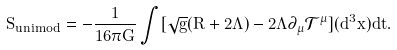Convert formula to latex. <formula><loc_0><loc_0><loc_500><loc_500>S _ { u n i m o d } = - \frac { 1 } { 1 6 \pi G } \int [ \sqrt { g } ( R + 2 \Lambda ) - 2 \Lambda \partial _ { \mu } { \mathcal { T } } ^ { \mu } ] ( d ^ { 3 } x ) d t .</formula> 